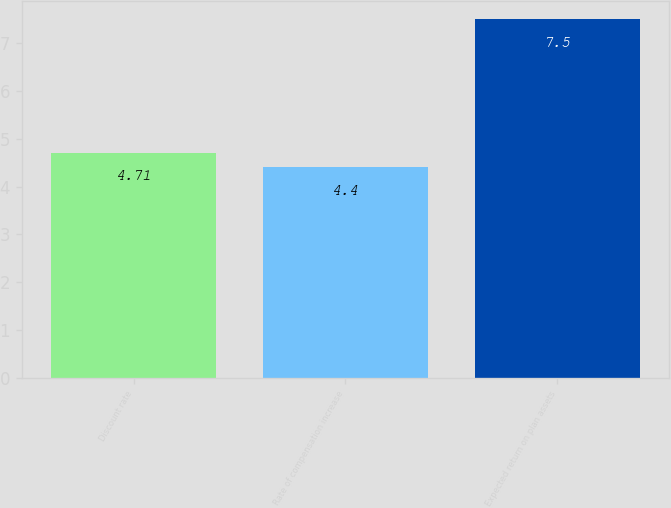Convert chart to OTSL. <chart><loc_0><loc_0><loc_500><loc_500><bar_chart><fcel>Discount rate<fcel>Rate of compensation increase<fcel>Expected return on plan assets<nl><fcel>4.71<fcel>4.4<fcel>7.5<nl></chart> 